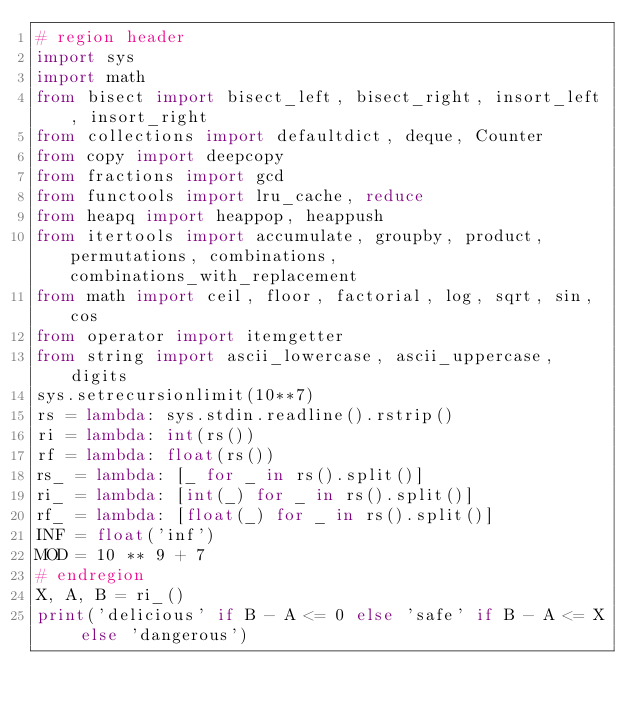Convert code to text. <code><loc_0><loc_0><loc_500><loc_500><_Python_># region header
import sys
import math
from bisect import bisect_left, bisect_right, insort_left, insort_right
from collections import defaultdict, deque, Counter
from copy import deepcopy
from fractions import gcd
from functools import lru_cache, reduce
from heapq import heappop, heappush
from itertools import accumulate, groupby, product, permutations, combinations, combinations_with_replacement
from math import ceil, floor, factorial, log, sqrt, sin, cos
from operator import itemgetter
from string import ascii_lowercase, ascii_uppercase, digits
sys.setrecursionlimit(10**7)
rs = lambda: sys.stdin.readline().rstrip()
ri = lambda: int(rs())
rf = lambda: float(rs())
rs_ = lambda: [_ for _ in rs().split()]
ri_ = lambda: [int(_) for _ in rs().split()]
rf_ = lambda: [float(_) for _ in rs().split()]
INF = float('inf')
MOD = 10 ** 9 + 7
# endregion
X, A, B = ri_()
print('delicious' if B - A <= 0 else 'safe' if B - A <= X else 'dangerous')</code> 